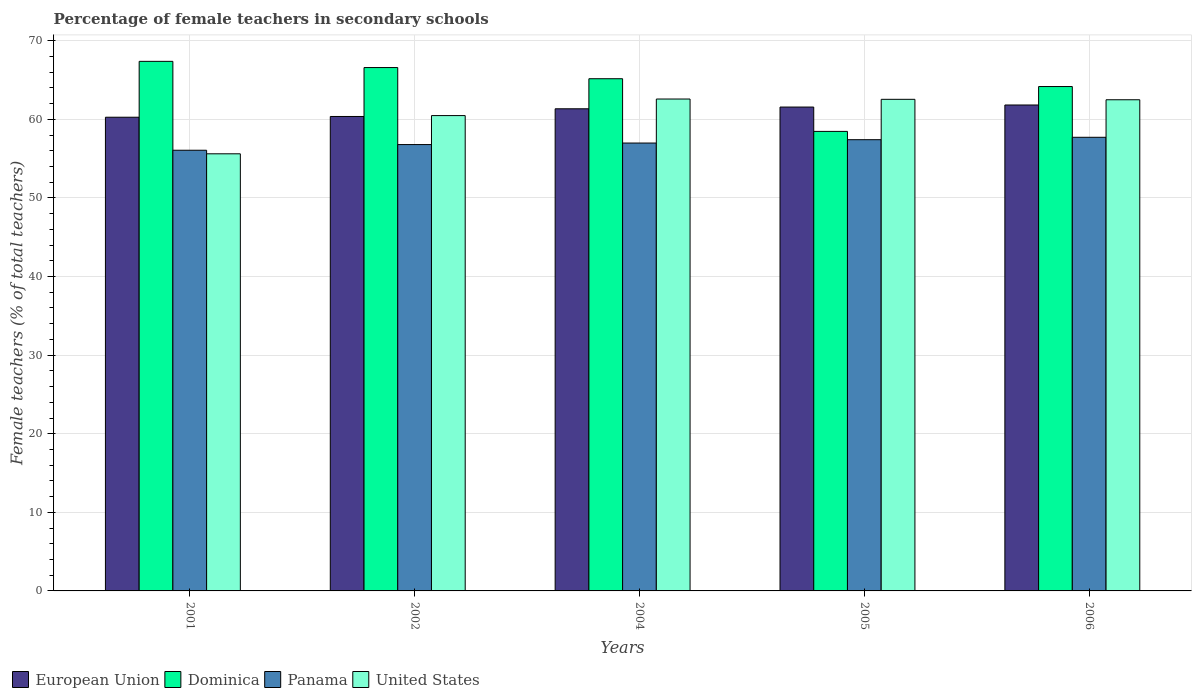How many groups of bars are there?
Your answer should be very brief. 5. Are the number of bars per tick equal to the number of legend labels?
Provide a short and direct response. Yes. Are the number of bars on each tick of the X-axis equal?
Your answer should be compact. Yes. How many bars are there on the 3rd tick from the left?
Provide a succinct answer. 4. How many bars are there on the 2nd tick from the right?
Your answer should be very brief. 4. What is the label of the 2nd group of bars from the left?
Provide a short and direct response. 2002. In how many cases, is the number of bars for a given year not equal to the number of legend labels?
Your answer should be very brief. 0. What is the percentage of female teachers in Panama in 2004?
Your response must be concise. 56.99. Across all years, what is the maximum percentage of female teachers in Dominica?
Provide a succinct answer. 67.38. Across all years, what is the minimum percentage of female teachers in United States?
Your answer should be compact. 55.62. In which year was the percentage of female teachers in European Union maximum?
Your response must be concise. 2006. In which year was the percentage of female teachers in Panama minimum?
Provide a succinct answer. 2001. What is the total percentage of female teachers in United States in the graph?
Make the answer very short. 303.73. What is the difference between the percentage of female teachers in United States in 2001 and that in 2006?
Provide a succinct answer. -6.88. What is the difference between the percentage of female teachers in Dominica in 2002 and the percentage of female teachers in European Union in 2004?
Ensure brevity in your answer.  5.25. What is the average percentage of female teachers in Panama per year?
Provide a succinct answer. 57. In the year 2004, what is the difference between the percentage of female teachers in United States and percentage of female teachers in Panama?
Your response must be concise. 5.6. What is the ratio of the percentage of female teachers in European Union in 2005 to that in 2006?
Give a very brief answer. 1. What is the difference between the highest and the second highest percentage of female teachers in United States?
Provide a succinct answer. 0.04. What is the difference between the highest and the lowest percentage of female teachers in European Union?
Offer a terse response. 1.55. In how many years, is the percentage of female teachers in Dominica greater than the average percentage of female teachers in Dominica taken over all years?
Your answer should be very brief. 3. Is the sum of the percentage of female teachers in European Union in 2001 and 2004 greater than the maximum percentage of female teachers in Panama across all years?
Offer a very short reply. Yes. Is it the case that in every year, the sum of the percentage of female teachers in United States and percentage of female teachers in Panama is greater than the sum of percentage of female teachers in Dominica and percentage of female teachers in European Union?
Your response must be concise. No. What does the 1st bar from the left in 2004 represents?
Provide a short and direct response. European Union. Is it the case that in every year, the sum of the percentage of female teachers in United States and percentage of female teachers in European Union is greater than the percentage of female teachers in Dominica?
Provide a short and direct response. Yes. Are all the bars in the graph horizontal?
Offer a very short reply. No. How many years are there in the graph?
Ensure brevity in your answer.  5. Are the values on the major ticks of Y-axis written in scientific E-notation?
Offer a terse response. No. Does the graph contain grids?
Make the answer very short. Yes. How are the legend labels stacked?
Make the answer very short. Horizontal. What is the title of the graph?
Your answer should be very brief. Percentage of female teachers in secondary schools. What is the label or title of the X-axis?
Provide a succinct answer. Years. What is the label or title of the Y-axis?
Provide a succinct answer. Female teachers (% of total teachers). What is the Female teachers (% of total teachers) in European Union in 2001?
Your response must be concise. 60.27. What is the Female teachers (% of total teachers) of Dominica in 2001?
Your answer should be compact. 67.38. What is the Female teachers (% of total teachers) in Panama in 2001?
Provide a short and direct response. 56.07. What is the Female teachers (% of total teachers) in United States in 2001?
Provide a short and direct response. 55.62. What is the Female teachers (% of total teachers) in European Union in 2002?
Give a very brief answer. 60.37. What is the Female teachers (% of total teachers) of Dominica in 2002?
Ensure brevity in your answer.  66.59. What is the Female teachers (% of total teachers) of Panama in 2002?
Your response must be concise. 56.79. What is the Female teachers (% of total teachers) in United States in 2002?
Make the answer very short. 60.48. What is the Female teachers (% of total teachers) in European Union in 2004?
Provide a short and direct response. 61.34. What is the Female teachers (% of total teachers) in Dominica in 2004?
Your response must be concise. 65.17. What is the Female teachers (% of total teachers) of Panama in 2004?
Provide a short and direct response. 56.99. What is the Female teachers (% of total teachers) in United States in 2004?
Provide a short and direct response. 62.59. What is the Female teachers (% of total teachers) of European Union in 2005?
Your answer should be very brief. 61.56. What is the Female teachers (% of total teachers) of Dominica in 2005?
Provide a short and direct response. 58.47. What is the Female teachers (% of total teachers) of Panama in 2005?
Your answer should be very brief. 57.41. What is the Female teachers (% of total teachers) of United States in 2005?
Your response must be concise. 62.55. What is the Female teachers (% of total teachers) in European Union in 2006?
Your answer should be very brief. 61.83. What is the Female teachers (% of total teachers) in Dominica in 2006?
Provide a succinct answer. 64.18. What is the Female teachers (% of total teachers) in Panama in 2006?
Offer a very short reply. 57.72. What is the Female teachers (% of total teachers) in United States in 2006?
Make the answer very short. 62.49. Across all years, what is the maximum Female teachers (% of total teachers) in European Union?
Keep it short and to the point. 61.83. Across all years, what is the maximum Female teachers (% of total teachers) in Dominica?
Provide a succinct answer. 67.38. Across all years, what is the maximum Female teachers (% of total teachers) in Panama?
Your answer should be very brief. 57.72. Across all years, what is the maximum Female teachers (% of total teachers) of United States?
Provide a short and direct response. 62.59. Across all years, what is the minimum Female teachers (% of total teachers) in European Union?
Provide a short and direct response. 60.27. Across all years, what is the minimum Female teachers (% of total teachers) of Dominica?
Ensure brevity in your answer.  58.47. Across all years, what is the minimum Female teachers (% of total teachers) in Panama?
Ensure brevity in your answer.  56.07. Across all years, what is the minimum Female teachers (% of total teachers) of United States?
Your answer should be very brief. 55.62. What is the total Female teachers (% of total teachers) in European Union in the graph?
Give a very brief answer. 305.37. What is the total Female teachers (% of total teachers) of Dominica in the graph?
Provide a succinct answer. 321.78. What is the total Female teachers (% of total teachers) in Panama in the graph?
Make the answer very short. 284.98. What is the total Female teachers (% of total teachers) in United States in the graph?
Give a very brief answer. 303.73. What is the difference between the Female teachers (% of total teachers) in European Union in 2001 and that in 2002?
Your answer should be compact. -0.1. What is the difference between the Female teachers (% of total teachers) of Dominica in 2001 and that in 2002?
Make the answer very short. 0.79. What is the difference between the Female teachers (% of total teachers) of Panama in 2001 and that in 2002?
Provide a short and direct response. -0.72. What is the difference between the Female teachers (% of total teachers) of United States in 2001 and that in 2002?
Make the answer very short. -4.86. What is the difference between the Female teachers (% of total teachers) in European Union in 2001 and that in 2004?
Give a very brief answer. -1.07. What is the difference between the Female teachers (% of total teachers) of Dominica in 2001 and that in 2004?
Provide a short and direct response. 2.21. What is the difference between the Female teachers (% of total teachers) in Panama in 2001 and that in 2004?
Your answer should be very brief. -0.92. What is the difference between the Female teachers (% of total teachers) of United States in 2001 and that in 2004?
Offer a very short reply. -6.97. What is the difference between the Female teachers (% of total teachers) in European Union in 2001 and that in 2005?
Your response must be concise. -1.29. What is the difference between the Female teachers (% of total teachers) in Dominica in 2001 and that in 2005?
Give a very brief answer. 8.91. What is the difference between the Female teachers (% of total teachers) in Panama in 2001 and that in 2005?
Your response must be concise. -1.34. What is the difference between the Female teachers (% of total teachers) in United States in 2001 and that in 2005?
Offer a very short reply. -6.93. What is the difference between the Female teachers (% of total teachers) in European Union in 2001 and that in 2006?
Ensure brevity in your answer.  -1.55. What is the difference between the Female teachers (% of total teachers) of Dominica in 2001 and that in 2006?
Make the answer very short. 3.2. What is the difference between the Female teachers (% of total teachers) of Panama in 2001 and that in 2006?
Your answer should be compact. -1.65. What is the difference between the Female teachers (% of total teachers) in United States in 2001 and that in 2006?
Keep it short and to the point. -6.88. What is the difference between the Female teachers (% of total teachers) of European Union in 2002 and that in 2004?
Your answer should be compact. -0.98. What is the difference between the Female teachers (% of total teachers) in Dominica in 2002 and that in 2004?
Make the answer very short. 1.42. What is the difference between the Female teachers (% of total teachers) of Panama in 2002 and that in 2004?
Keep it short and to the point. -0.19. What is the difference between the Female teachers (% of total teachers) of United States in 2002 and that in 2004?
Keep it short and to the point. -2.11. What is the difference between the Female teachers (% of total teachers) of European Union in 2002 and that in 2005?
Your answer should be compact. -1.2. What is the difference between the Female teachers (% of total teachers) of Dominica in 2002 and that in 2005?
Your answer should be very brief. 8.12. What is the difference between the Female teachers (% of total teachers) in Panama in 2002 and that in 2005?
Keep it short and to the point. -0.62. What is the difference between the Female teachers (% of total teachers) in United States in 2002 and that in 2005?
Provide a short and direct response. -2.07. What is the difference between the Female teachers (% of total teachers) in European Union in 2002 and that in 2006?
Your response must be concise. -1.46. What is the difference between the Female teachers (% of total teachers) of Dominica in 2002 and that in 2006?
Provide a short and direct response. 2.42. What is the difference between the Female teachers (% of total teachers) of Panama in 2002 and that in 2006?
Your response must be concise. -0.93. What is the difference between the Female teachers (% of total teachers) in United States in 2002 and that in 2006?
Give a very brief answer. -2.01. What is the difference between the Female teachers (% of total teachers) of European Union in 2004 and that in 2005?
Provide a succinct answer. -0.22. What is the difference between the Female teachers (% of total teachers) in Dominica in 2004 and that in 2005?
Provide a succinct answer. 6.7. What is the difference between the Female teachers (% of total teachers) in Panama in 2004 and that in 2005?
Offer a very short reply. -0.43. What is the difference between the Female teachers (% of total teachers) of United States in 2004 and that in 2005?
Offer a very short reply. 0.04. What is the difference between the Female teachers (% of total teachers) in European Union in 2004 and that in 2006?
Give a very brief answer. -0.48. What is the difference between the Female teachers (% of total teachers) of Panama in 2004 and that in 2006?
Ensure brevity in your answer.  -0.73. What is the difference between the Female teachers (% of total teachers) in United States in 2004 and that in 2006?
Offer a very short reply. 0.09. What is the difference between the Female teachers (% of total teachers) in European Union in 2005 and that in 2006?
Make the answer very short. -0.26. What is the difference between the Female teachers (% of total teachers) of Dominica in 2005 and that in 2006?
Make the answer very short. -5.71. What is the difference between the Female teachers (% of total teachers) of Panama in 2005 and that in 2006?
Provide a succinct answer. -0.31. What is the difference between the Female teachers (% of total teachers) in United States in 2005 and that in 2006?
Your response must be concise. 0.06. What is the difference between the Female teachers (% of total teachers) in European Union in 2001 and the Female teachers (% of total teachers) in Dominica in 2002?
Make the answer very short. -6.32. What is the difference between the Female teachers (% of total teachers) of European Union in 2001 and the Female teachers (% of total teachers) of Panama in 2002?
Your answer should be compact. 3.48. What is the difference between the Female teachers (% of total teachers) of European Union in 2001 and the Female teachers (% of total teachers) of United States in 2002?
Give a very brief answer. -0.21. What is the difference between the Female teachers (% of total teachers) in Dominica in 2001 and the Female teachers (% of total teachers) in Panama in 2002?
Give a very brief answer. 10.59. What is the difference between the Female teachers (% of total teachers) in Dominica in 2001 and the Female teachers (% of total teachers) in United States in 2002?
Offer a very short reply. 6.9. What is the difference between the Female teachers (% of total teachers) in Panama in 2001 and the Female teachers (% of total teachers) in United States in 2002?
Provide a succinct answer. -4.41. What is the difference between the Female teachers (% of total teachers) in European Union in 2001 and the Female teachers (% of total teachers) in Dominica in 2004?
Provide a succinct answer. -4.9. What is the difference between the Female teachers (% of total teachers) of European Union in 2001 and the Female teachers (% of total teachers) of Panama in 2004?
Offer a terse response. 3.28. What is the difference between the Female teachers (% of total teachers) in European Union in 2001 and the Female teachers (% of total teachers) in United States in 2004?
Provide a short and direct response. -2.32. What is the difference between the Female teachers (% of total teachers) of Dominica in 2001 and the Female teachers (% of total teachers) of Panama in 2004?
Offer a very short reply. 10.39. What is the difference between the Female teachers (% of total teachers) of Dominica in 2001 and the Female teachers (% of total teachers) of United States in 2004?
Provide a short and direct response. 4.79. What is the difference between the Female teachers (% of total teachers) in Panama in 2001 and the Female teachers (% of total teachers) in United States in 2004?
Your answer should be compact. -6.52. What is the difference between the Female teachers (% of total teachers) in European Union in 2001 and the Female teachers (% of total teachers) in Dominica in 2005?
Offer a terse response. 1.8. What is the difference between the Female teachers (% of total teachers) in European Union in 2001 and the Female teachers (% of total teachers) in Panama in 2005?
Offer a terse response. 2.86. What is the difference between the Female teachers (% of total teachers) in European Union in 2001 and the Female teachers (% of total teachers) in United States in 2005?
Offer a terse response. -2.28. What is the difference between the Female teachers (% of total teachers) of Dominica in 2001 and the Female teachers (% of total teachers) of Panama in 2005?
Your response must be concise. 9.97. What is the difference between the Female teachers (% of total teachers) of Dominica in 2001 and the Female teachers (% of total teachers) of United States in 2005?
Ensure brevity in your answer.  4.83. What is the difference between the Female teachers (% of total teachers) in Panama in 2001 and the Female teachers (% of total teachers) in United States in 2005?
Offer a very short reply. -6.48. What is the difference between the Female teachers (% of total teachers) of European Union in 2001 and the Female teachers (% of total teachers) of Dominica in 2006?
Your answer should be compact. -3.9. What is the difference between the Female teachers (% of total teachers) of European Union in 2001 and the Female teachers (% of total teachers) of Panama in 2006?
Provide a succinct answer. 2.55. What is the difference between the Female teachers (% of total teachers) in European Union in 2001 and the Female teachers (% of total teachers) in United States in 2006?
Make the answer very short. -2.22. What is the difference between the Female teachers (% of total teachers) of Dominica in 2001 and the Female teachers (% of total teachers) of Panama in 2006?
Your answer should be compact. 9.66. What is the difference between the Female teachers (% of total teachers) of Dominica in 2001 and the Female teachers (% of total teachers) of United States in 2006?
Make the answer very short. 4.89. What is the difference between the Female teachers (% of total teachers) of Panama in 2001 and the Female teachers (% of total teachers) of United States in 2006?
Give a very brief answer. -6.42. What is the difference between the Female teachers (% of total teachers) in European Union in 2002 and the Female teachers (% of total teachers) in Dominica in 2004?
Offer a very short reply. -4.8. What is the difference between the Female teachers (% of total teachers) of European Union in 2002 and the Female teachers (% of total teachers) of Panama in 2004?
Ensure brevity in your answer.  3.38. What is the difference between the Female teachers (% of total teachers) of European Union in 2002 and the Female teachers (% of total teachers) of United States in 2004?
Ensure brevity in your answer.  -2.22. What is the difference between the Female teachers (% of total teachers) of Dominica in 2002 and the Female teachers (% of total teachers) of Panama in 2004?
Offer a terse response. 9.6. What is the difference between the Female teachers (% of total teachers) in Dominica in 2002 and the Female teachers (% of total teachers) in United States in 2004?
Offer a terse response. 4. What is the difference between the Female teachers (% of total teachers) in Panama in 2002 and the Female teachers (% of total teachers) in United States in 2004?
Your answer should be compact. -5.79. What is the difference between the Female teachers (% of total teachers) of European Union in 2002 and the Female teachers (% of total teachers) of Dominica in 2005?
Give a very brief answer. 1.9. What is the difference between the Female teachers (% of total teachers) in European Union in 2002 and the Female teachers (% of total teachers) in Panama in 2005?
Make the answer very short. 2.95. What is the difference between the Female teachers (% of total teachers) of European Union in 2002 and the Female teachers (% of total teachers) of United States in 2005?
Keep it short and to the point. -2.18. What is the difference between the Female teachers (% of total teachers) in Dominica in 2002 and the Female teachers (% of total teachers) in Panama in 2005?
Provide a succinct answer. 9.18. What is the difference between the Female teachers (% of total teachers) in Dominica in 2002 and the Female teachers (% of total teachers) in United States in 2005?
Make the answer very short. 4.04. What is the difference between the Female teachers (% of total teachers) in Panama in 2002 and the Female teachers (% of total teachers) in United States in 2005?
Offer a terse response. -5.76. What is the difference between the Female teachers (% of total teachers) of European Union in 2002 and the Female teachers (% of total teachers) of Dominica in 2006?
Your answer should be compact. -3.81. What is the difference between the Female teachers (% of total teachers) in European Union in 2002 and the Female teachers (% of total teachers) in Panama in 2006?
Your answer should be very brief. 2.65. What is the difference between the Female teachers (% of total teachers) of European Union in 2002 and the Female teachers (% of total teachers) of United States in 2006?
Make the answer very short. -2.13. What is the difference between the Female teachers (% of total teachers) of Dominica in 2002 and the Female teachers (% of total teachers) of Panama in 2006?
Offer a very short reply. 8.87. What is the difference between the Female teachers (% of total teachers) in Dominica in 2002 and the Female teachers (% of total teachers) in United States in 2006?
Your answer should be very brief. 4.1. What is the difference between the Female teachers (% of total teachers) in Panama in 2002 and the Female teachers (% of total teachers) in United States in 2006?
Ensure brevity in your answer.  -5.7. What is the difference between the Female teachers (% of total teachers) of European Union in 2004 and the Female teachers (% of total teachers) of Dominica in 2005?
Offer a terse response. 2.88. What is the difference between the Female teachers (% of total teachers) in European Union in 2004 and the Female teachers (% of total teachers) in Panama in 2005?
Provide a succinct answer. 3.93. What is the difference between the Female teachers (% of total teachers) in European Union in 2004 and the Female teachers (% of total teachers) in United States in 2005?
Your answer should be very brief. -1.2. What is the difference between the Female teachers (% of total teachers) in Dominica in 2004 and the Female teachers (% of total teachers) in Panama in 2005?
Give a very brief answer. 7.76. What is the difference between the Female teachers (% of total teachers) of Dominica in 2004 and the Female teachers (% of total teachers) of United States in 2005?
Your answer should be very brief. 2.62. What is the difference between the Female teachers (% of total teachers) in Panama in 2004 and the Female teachers (% of total teachers) in United States in 2005?
Provide a succinct answer. -5.56. What is the difference between the Female teachers (% of total teachers) of European Union in 2004 and the Female teachers (% of total teachers) of Dominica in 2006?
Make the answer very short. -2.83. What is the difference between the Female teachers (% of total teachers) of European Union in 2004 and the Female teachers (% of total teachers) of Panama in 2006?
Give a very brief answer. 3.63. What is the difference between the Female teachers (% of total teachers) in European Union in 2004 and the Female teachers (% of total teachers) in United States in 2006?
Provide a short and direct response. -1.15. What is the difference between the Female teachers (% of total teachers) in Dominica in 2004 and the Female teachers (% of total teachers) in Panama in 2006?
Ensure brevity in your answer.  7.45. What is the difference between the Female teachers (% of total teachers) in Dominica in 2004 and the Female teachers (% of total teachers) in United States in 2006?
Ensure brevity in your answer.  2.68. What is the difference between the Female teachers (% of total teachers) in Panama in 2004 and the Female teachers (% of total teachers) in United States in 2006?
Provide a succinct answer. -5.51. What is the difference between the Female teachers (% of total teachers) of European Union in 2005 and the Female teachers (% of total teachers) of Dominica in 2006?
Keep it short and to the point. -2.61. What is the difference between the Female teachers (% of total teachers) in European Union in 2005 and the Female teachers (% of total teachers) in Panama in 2006?
Provide a short and direct response. 3.85. What is the difference between the Female teachers (% of total teachers) of European Union in 2005 and the Female teachers (% of total teachers) of United States in 2006?
Provide a short and direct response. -0.93. What is the difference between the Female teachers (% of total teachers) in Dominica in 2005 and the Female teachers (% of total teachers) in Panama in 2006?
Your response must be concise. 0.75. What is the difference between the Female teachers (% of total teachers) of Dominica in 2005 and the Female teachers (% of total teachers) of United States in 2006?
Keep it short and to the point. -4.03. What is the difference between the Female teachers (% of total teachers) of Panama in 2005 and the Female teachers (% of total teachers) of United States in 2006?
Provide a short and direct response. -5.08. What is the average Female teachers (% of total teachers) in European Union per year?
Keep it short and to the point. 61.07. What is the average Female teachers (% of total teachers) of Dominica per year?
Make the answer very short. 64.36. What is the average Female teachers (% of total teachers) of Panama per year?
Your response must be concise. 57. What is the average Female teachers (% of total teachers) in United States per year?
Offer a very short reply. 60.75. In the year 2001, what is the difference between the Female teachers (% of total teachers) in European Union and Female teachers (% of total teachers) in Dominica?
Ensure brevity in your answer.  -7.11. In the year 2001, what is the difference between the Female teachers (% of total teachers) of European Union and Female teachers (% of total teachers) of Panama?
Ensure brevity in your answer.  4.2. In the year 2001, what is the difference between the Female teachers (% of total teachers) of European Union and Female teachers (% of total teachers) of United States?
Keep it short and to the point. 4.65. In the year 2001, what is the difference between the Female teachers (% of total teachers) in Dominica and Female teachers (% of total teachers) in Panama?
Make the answer very short. 11.31. In the year 2001, what is the difference between the Female teachers (% of total teachers) in Dominica and Female teachers (% of total teachers) in United States?
Make the answer very short. 11.76. In the year 2001, what is the difference between the Female teachers (% of total teachers) in Panama and Female teachers (% of total teachers) in United States?
Your response must be concise. 0.45. In the year 2002, what is the difference between the Female teachers (% of total teachers) of European Union and Female teachers (% of total teachers) of Dominica?
Offer a terse response. -6.22. In the year 2002, what is the difference between the Female teachers (% of total teachers) of European Union and Female teachers (% of total teachers) of Panama?
Your answer should be compact. 3.57. In the year 2002, what is the difference between the Female teachers (% of total teachers) of European Union and Female teachers (% of total teachers) of United States?
Offer a very short reply. -0.11. In the year 2002, what is the difference between the Female teachers (% of total teachers) in Dominica and Female teachers (% of total teachers) in Panama?
Your answer should be compact. 9.8. In the year 2002, what is the difference between the Female teachers (% of total teachers) in Dominica and Female teachers (% of total teachers) in United States?
Provide a short and direct response. 6.11. In the year 2002, what is the difference between the Female teachers (% of total teachers) of Panama and Female teachers (% of total teachers) of United States?
Offer a very short reply. -3.69. In the year 2004, what is the difference between the Female teachers (% of total teachers) in European Union and Female teachers (% of total teachers) in Dominica?
Provide a succinct answer. -3.82. In the year 2004, what is the difference between the Female teachers (% of total teachers) of European Union and Female teachers (% of total teachers) of Panama?
Provide a succinct answer. 4.36. In the year 2004, what is the difference between the Female teachers (% of total teachers) of European Union and Female teachers (% of total teachers) of United States?
Your response must be concise. -1.24. In the year 2004, what is the difference between the Female teachers (% of total teachers) of Dominica and Female teachers (% of total teachers) of Panama?
Your answer should be very brief. 8.18. In the year 2004, what is the difference between the Female teachers (% of total teachers) in Dominica and Female teachers (% of total teachers) in United States?
Make the answer very short. 2.58. In the year 2004, what is the difference between the Female teachers (% of total teachers) of Panama and Female teachers (% of total teachers) of United States?
Provide a short and direct response. -5.6. In the year 2005, what is the difference between the Female teachers (% of total teachers) of European Union and Female teachers (% of total teachers) of Dominica?
Provide a succinct answer. 3.1. In the year 2005, what is the difference between the Female teachers (% of total teachers) of European Union and Female teachers (% of total teachers) of Panama?
Provide a short and direct response. 4.15. In the year 2005, what is the difference between the Female teachers (% of total teachers) of European Union and Female teachers (% of total teachers) of United States?
Ensure brevity in your answer.  -0.98. In the year 2005, what is the difference between the Female teachers (% of total teachers) of Dominica and Female teachers (% of total teachers) of Panama?
Offer a very short reply. 1.06. In the year 2005, what is the difference between the Female teachers (% of total teachers) of Dominica and Female teachers (% of total teachers) of United States?
Your response must be concise. -4.08. In the year 2005, what is the difference between the Female teachers (% of total teachers) of Panama and Female teachers (% of total teachers) of United States?
Your response must be concise. -5.14. In the year 2006, what is the difference between the Female teachers (% of total teachers) of European Union and Female teachers (% of total teachers) of Dominica?
Make the answer very short. -2.35. In the year 2006, what is the difference between the Female teachers (% of total teachers) in European Union and Female teachers (% of total teachers) in Panama?
Your answer should be compact. 4.11. In the year 2006, what is the difference between the Female teachers (% of total teachers) of European Union and Female teachers (% of total teachers) of United States?
Your answer should be compact. -0.67. In the year 2006, what is the difference between the Female teachers (% of total teachers) in Dominica and Female teachers (% of total teachers) in Panama?
Your answer should be compact. 6.46. In the year 2006, what is the difference between the Female teachers (% of total teachers) in Dominica and Female teachers (% of total teachers) in United States?
Provide a short and direct response. 1.68. In the year 2006, what is the difference between the Female teachers (% of total teachers) of Panama and Female teachers (% of total teachers) of United States?
Your answer should be compact. -4.77. What is the ratio of the Female teachers (% of total teachers) in Dominica in 2001 to that in 2002?
Your response must be concise. 1.01. What is the ratio of the Female teachers (% of total teachers) of Panama in 2001 to that in 2002?
Offer a terse response. 0.99. What is the ratio of the Female teachers (% of total teachers) in United States in 2001 to that in 2002?
Your answer should be compact. 0.92. What is the ratio of the Female teachers (% of total teachers) of European Union in 2001 to that in 2004?
Provide a short and direct response. 0.98. What is the ratio of the Female teachers (% of total teachers) in Dominica in 2001 to that in 2004?
Ensure brevity in your answer.  1.03. What is the ratio of the Female teachers (% of total teachers) of Panama in 2001 to that in 2004?
Make the answer very short. 0.98. What is the ratio of the Female teachers (% of total teachers) in United States in 2001 to that in 2004?
Give a very brief answer. 0.89. What is the ratio of the Female teachers (% of total teachers) of Dominica in 2001 to that in 2005?
Provide a short and direct response. 1.15. What is the ratio of the Female teachers (% of total teachers) in Panama in 2001 to that in 2005?
Keep it short and to the point. 0.98. What is the ratio of the Female teachers (% of total teachers) of United States in 2001 to that in 2005?
Keep it short and to the point. 0.89. What is the ratio of the Female teachers (% of total teachers) of European Union in 2001 to that in 2006?
Give a very brief answer. 0.97. What is the ratio of the Female teachers (% of total teachers) of Dominica in 2001 to that in 2006?
Give a very brief answer. 1.05. What is the ratio of the Female teachers (% of total teachers) in Panama in 2001 to that in 2006?
Keep it short and to the point. 0.97. What is the ratio of the Female teachers (% of total teachers) in United States in 2001 to that in 2006?
Provide a short and direct response. 0.89. What is the ratio of the Female teachers (% of total teachers) of European Union in 2002 to that in 2004?
Keep it short and to the point. 0.98. What is the ratio of the Female teachers (% of total teachers) of Dominica in 2002 to that in 2004?
Your answer should be very brief. 1.02. What is the ratio of the Female teachers (% of total teachers) in United States in 2002 to that in 2004?
Provide a short and direct response. 0.97. What is the ratio of the Female teachers (% of total teachers) of European Union in 2002 to that in 2005?
Your response must be concise. 0.98. What is the ratio of the Female teachers (% of total teachers) in Dominica in 2002 to that in 2005?
Offer a very short reply. 1.14. What is the ratio of the Female teachers (% of total teachers) of United States in 2002 to that in 2005?
Your response must be concise. 0.97. What is the ratio of the Female teachers (% of total teachers) in European Union in 2002 to that in 2006?
Offer a terse response. 0.98. What is the ratio of the Female teachers (% of total teachers) of Dominica in 2002 to that in 2006?
Provide a short and direct response. 1.04. What is the ratio of the Female teachers (% of total teachers) in Panama in 2002 to that in 2006?
Offer a terse response. 0.98. What is the ratio of the Female teachers (% of total teachers) of United States in 2002 to that in 2006?
Offer a terse response. 0.97. What is the ratio of the Female teachers (% of total teachers) of Dominica in 2004 to that in 2005?
Offer a terse response. 1.11. What is the ratio of the Female teachers (% of total teachers) of Panama in 2004 to that in 2005?
Your response must be concise. 0.99. What is the ratio of the Female teachers (% of total teachers) of United States in 2004 to that in 2005?
Your response must be concise. 1. What is the ratio of the Female teachers (% of total teachers) in Dominica in 2004 to that in 2006?
Give a very brief answer. 1.02. What is the ratio of the Female teachers (% of total teachers) in Panama in 2004 to that in 2006?
Your response must be concise. 0.99. What is the ratio of the Female teachers (% of total teachers) of United States in 2004 to that in 2006?
Provide a short and direct response. 1. What is the ratio of the Female teachers (% of total teachers) of European Union in 2005 to that in 2006?
Provide a succinct answer. 1. What is the ratio of the Female teachers (% of total teachers) in Dominica in 2005 to that in 2006?
Provide a succinct answer. 0.91. What is the ratio of the Female teachers (% of total teachers) of Panama in 2005 to that in 2006?
Keep it short and to the point. 0.99. What is the ratio of the Female teachers (% of total teachers) of United States in 2005 to that in 2006?
Make the answer very short. 1. What is the difference between the highest and the second highest Female teachers (% of total teachers) in European Union?
Provide a short and direct response. 0.26. What is the difference between the highest and the second highest Female teachers (% of total teachers) in Dominica?
Your answer should be compact. 0.79. What is the difference between the highest and the second highest Female teachers (% of total teachers) of Panama?
Your answer should be very brief. 0.31. What is the difference between the highest and the second highest Female teachers (% of total teachers) of United States?
Make the answer very short. 0.04. What is the difference between the highest and the lowest Female teachers (% of total teachers) of European Union?
Keep it short and to the point. 1.55. What is the difference between the highest and the lowest Female teachers (% of total teachers) of Dominica?
Ensure brevity in your answer.  8.91. What is the difference between the highest and the lowest Female teachers (% of total teachers) of Panama?
Offer a very short reply. 1.65. What is the difference between the highest and the lowest Female teachers (% of total teachers) of United States?
Keep it short and to the point. 6.97. 